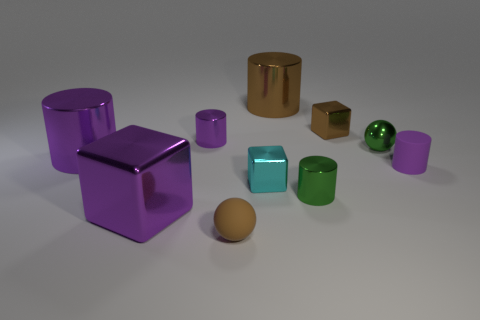There is a small shiny cylinder that is in front of the tiny ball behind the small purple matte cylinder; are there any big purple shiny blocks that are behind it?
Ensure brevity in your answer.  No. How many other objects are the same color as the matte ball?
Provide a short and direct response. 2. There is a metallic cube behind the metal sphere; is its size the same as the green metal thing in front of the small cyan object?
Make the answer very short. Yes. Are there an equal number of small brown things behind the big block and big purple objects that are in front of the large purple cylinder?
Keep it short and to the point. Yes. Is the size of the green cylinder the same as the ball that is behind the large shiny block?
Make the answer very short. Yes. There is a small purple cylinder behind the tiny green shiny thing behind the matte cylinder; what is it made of?
Offer a very short reply. Metal. Are there the same number of cyan shiny objects that are behind the brown block and large blue shiny cylinders?
Keep it short and to the point. Yes. There is a purple cylinder that is both in front of the green sphere and left of the shiny sphere; how big is it?
Offer a very short reply. Large. The large metal object in front of the small matte thing behind the brown matte thing is what color?
Give a very brief answer. Purple. What number of purple objects are either small metal cylinders or big rubber spheres?
Provide a short and direct response. 1. 